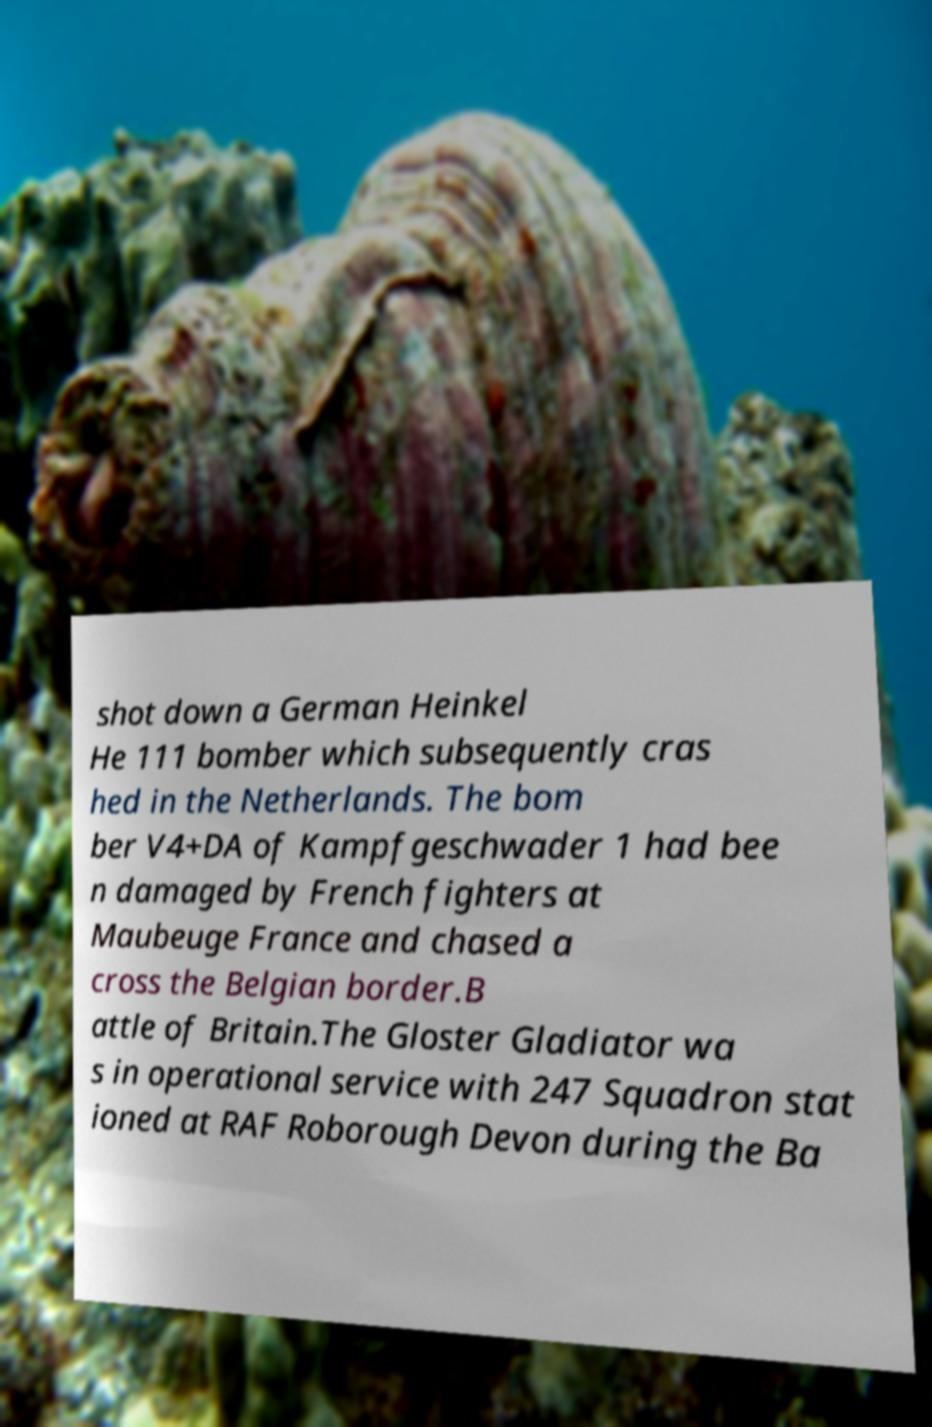Please identify and transcribe the text found in this image. shot down a German Heinkel He 111 bomber which subsequently cras hed in the Netherlands. The bom ber V4+DA of Kampfgeschwader 1 had bee n damaged by French fighters at Maubeuge France and chased a cross the Belgian border.B attle of Britain.The Gloster Gladiator wa s in operational service with 247 Squadron stat ioned at RAF Roborough Devon during the Ba 